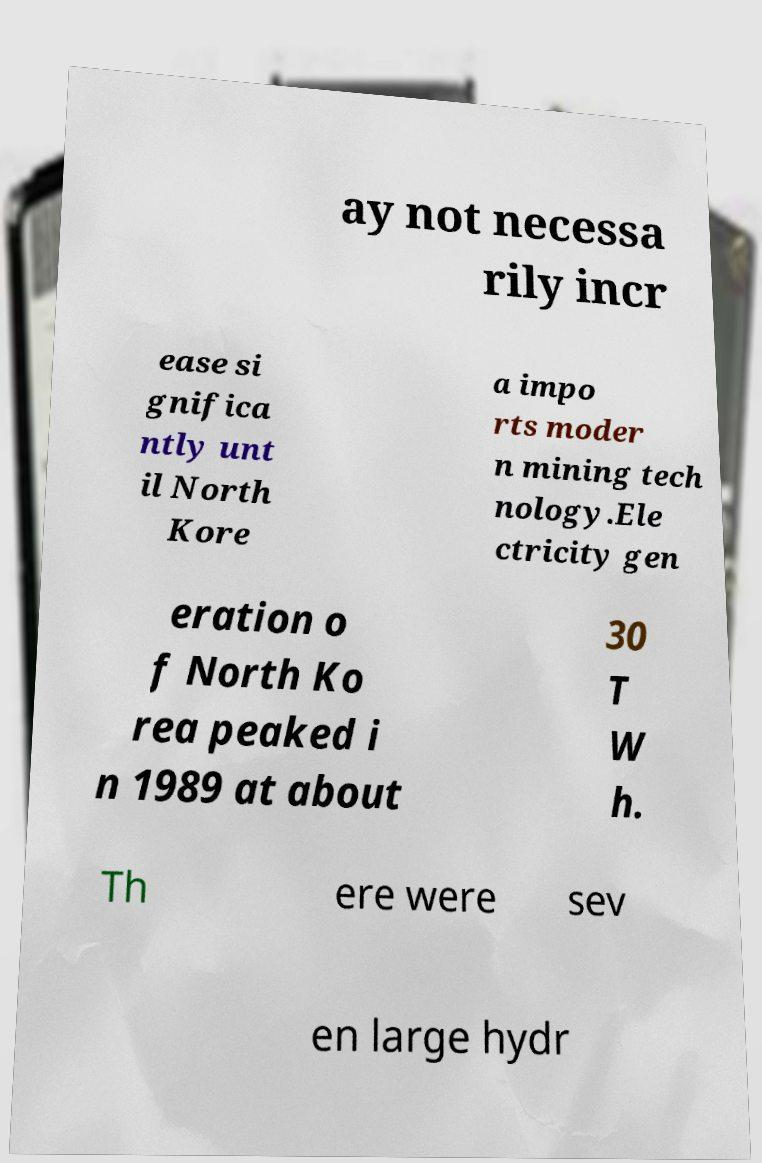For documentation purposes, I need the text within this image transcribed. Could you provide that? ay not necessa rily incr ease si gnifica ntly unt il North Kore a impo rts moder n mining tech nology.Ele ctricity gen eration o f North Ko rea peaked i n 1989 at about 30 T W h. Th ere were sev en large hydr 